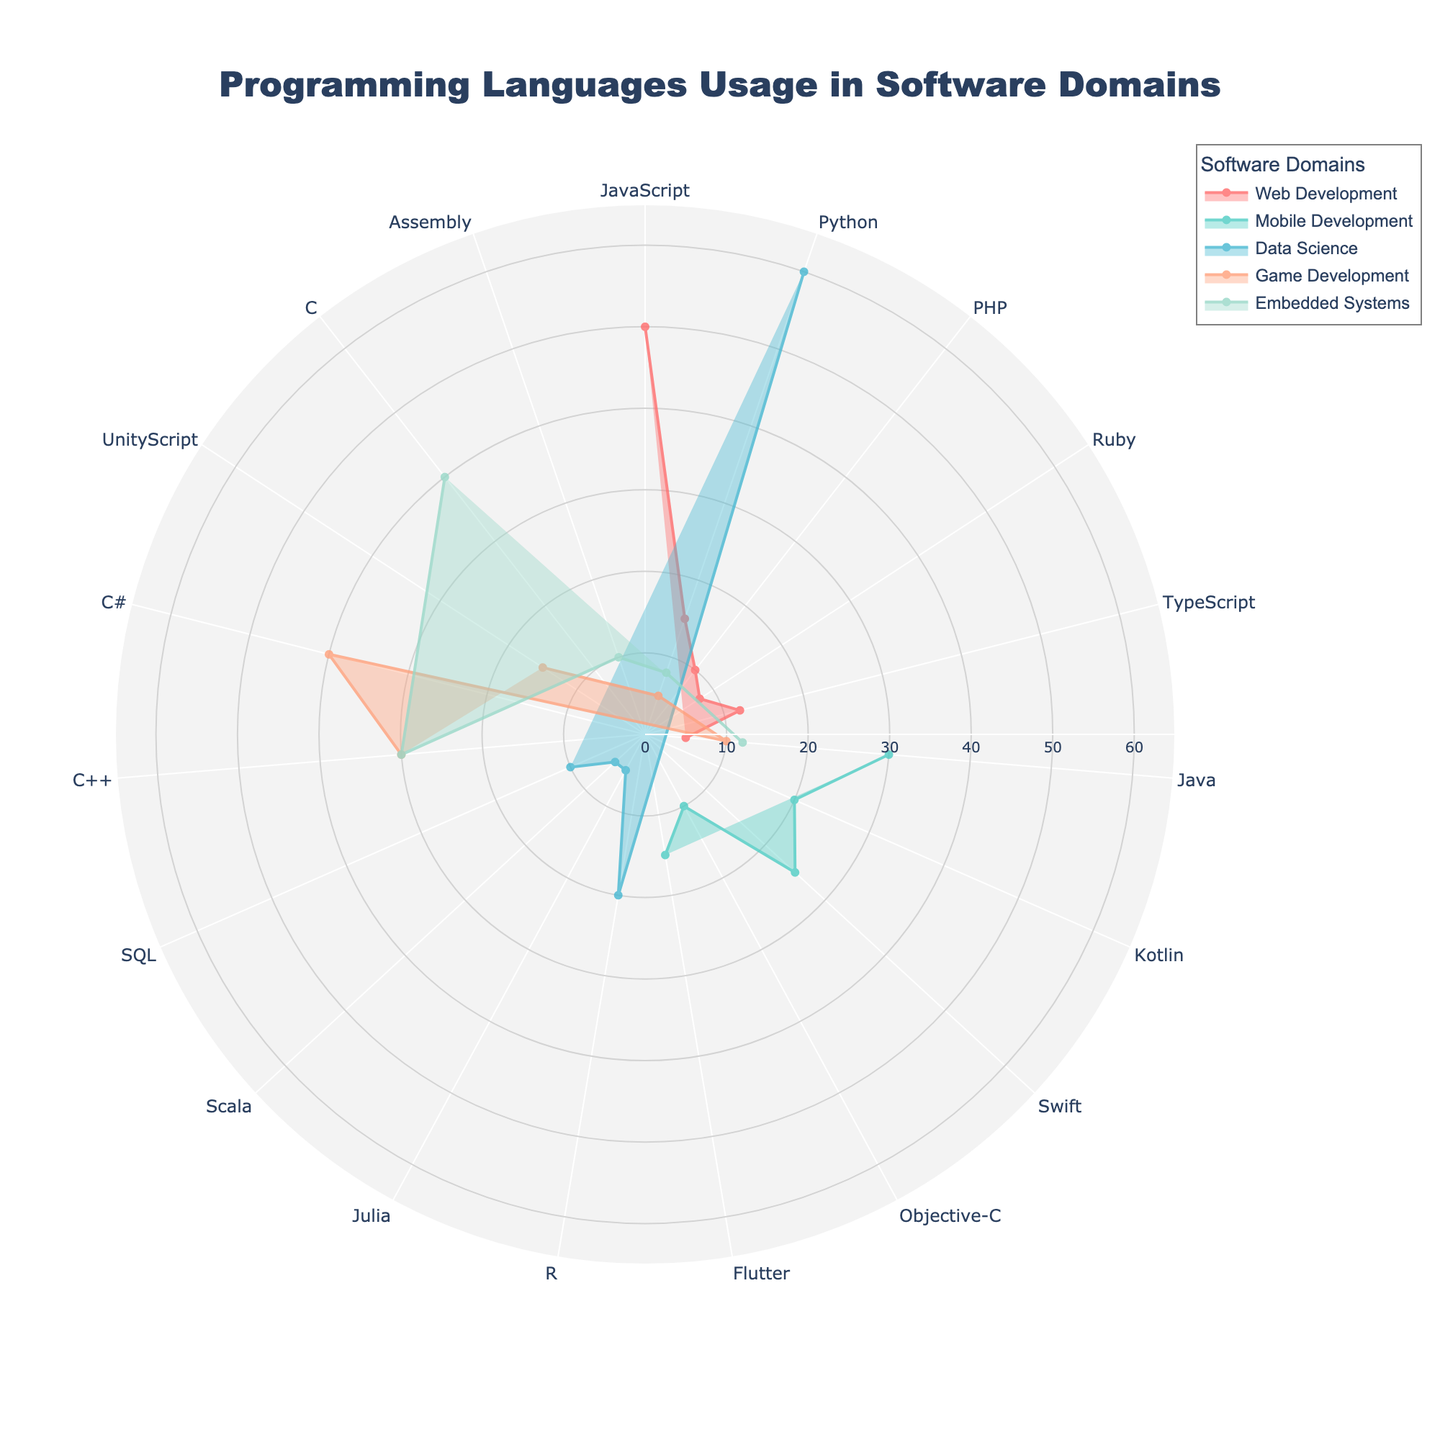What is the title of the figure? The title is prominently displayed at the top center of the figure, reading "Programming Languages Usage in Software Domains".
Answer: Programming Languages Usage in Software Domains Which software domain has the highest usage percentage for Java? By examining the polar chart, we can observe that Mobile Development has the highest usage percentage for Java at 30%.
Answer: Mobile Development What is the most used programming language in Embedded Systems? In the sector for Embedded Systems, we can see that the widest segment, hence the highest usage percentage, is for C at 40%.
Answer: C How does Python usage in Data Science compare to its usage in Web Development? Data Science shows a 60% usage of Python, while Web Development shows a 15% usage. Python is significantly more used in Data Science compared to Web Development.
Answer: Python is significantly more used in Data Science Which software domain has the most diverse set of programming languages? Each sector represents a software domain and its variety of programming languages. Web Development shows the most diverse set with JavaScript, Python, PHP, Ruby, TypeScript, and Java.
Answer: Web Development What is the sum of the usage percentages for Java across all domains? We sum the individual percentages of Java from each domain: 5% (Web Development) + 30% (Mobile Development) + 10% (Game Development) + 12% (Embedded Systems) = 57%.
Answer: 57% Which domain shows the highest aggregate usage for all programming languages combined? To find this, we would add up the usage percentages for all languages within each domain. By visually inspecting the sectors, Data Science appears to have the most substantial total with 60% (Python) + 20% (R) + 5% (Julia) + 5% (Scala) + 10% (SQL) = 100%.
Answer: Data Science How does the C++ usage in Game Development compare with that in Embedded Systems? Looking at the chart, C++ is shown at 30% in both Game Development and Embedded Systems. Both domains have an equal C++ usage.
Answer: Both have equal C++ usage at 30% What is the average usage percentage of programming languages in Web Development? To compute the average, we sum the percentages and divide by the number of languages: (50 + 15 + 10 + 8 + 12 + 5) / 6 = 100 / 6 ≈ 16.67%.
Answer: ~16.67% Based on the chart, which languages are used in both Mobile Development and Data Science? Observing the data for both domains, Python is used in Data Science (60%) and Web Development (is 15%), and Java is used in Data Science (50%) and in Web Development (15%).
Answer: Python, Java 